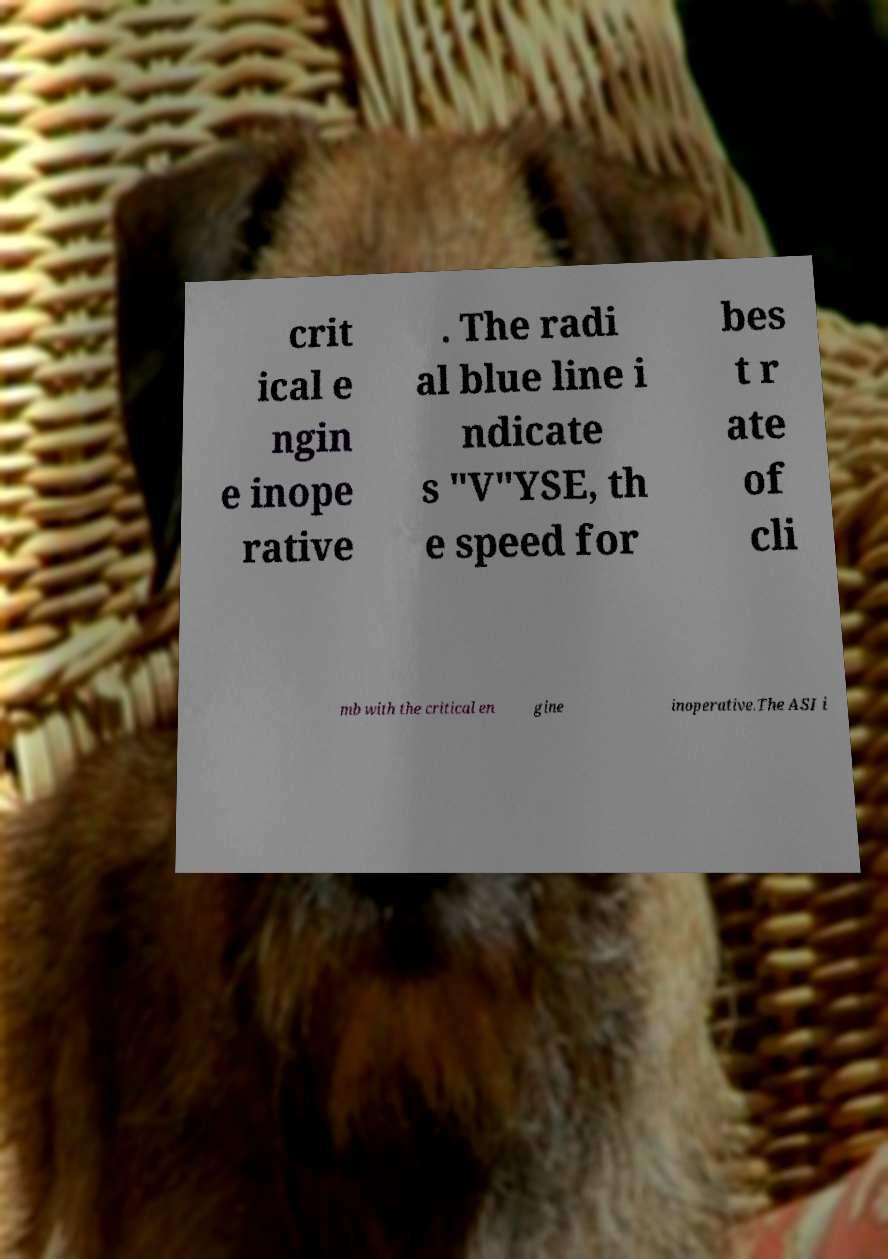I need the written content from this picture converted into text. Can you do that? crit ical e ngin e inope rative . The radi al blue line i ndicate s "V"YSE, th e speed for bes t r ate of cli mb with the critical en gine inoperative.The ASI i 